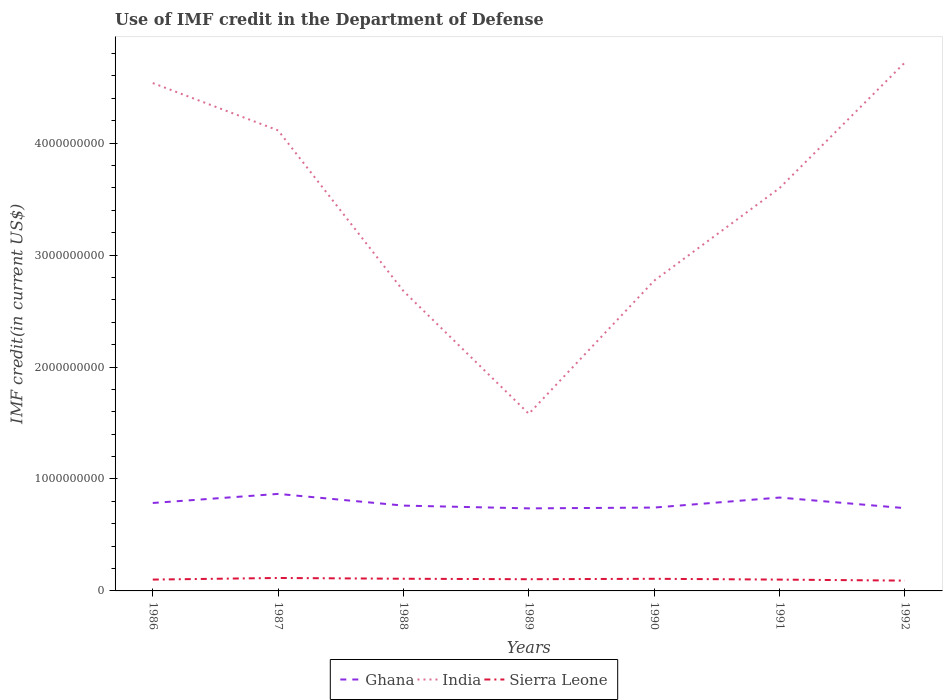How many different coloured lines are there?
Provide a succinct answer. 3. Across all years, what is the maximum IMF credit in the Department of Defense in Sierra Leone?
Your answer should be very brief. 9.21e+07. What is the total IMF credit in the Department of Defense in India in the graph?
Keep it short and to the point. -3.14e+09. What is the difference between the highest and the second highest IMF credit in the Department of Defense in Ghana?
Your answer should be compact. 1.29e+08. How many years are there in the graph?
Provide a succinct answer. 7. What is the difference between two consecutive major ticks on the Y-axis?
Provide a succinct answer. 1.00e+09. Are the values on the major ticks of Y-axis written in scientific E-notation?
Give a very brief answer. No. Does the graph contain grids?
Ensure brevity in your answer.  No. Where does the legend appear in the graph?
Provide a short and direct response. Bottom center. How are the legend labels stacked?
Ensure brevity in your answer.  Horizontal. What is the title of the graph?
Provide a short and direct response. Use of IMF credit in the Department of Defense. Does "Czech Republic" appear as one of the legend labels in the graph?
Your answer should be compact. No. What is the label or title of the Y-axis?
Your answer should be compact. IMF credit(in current US$). What is the IMF credit(in current US$) of Ghana in 1986?
Provide a succinct answer. 7.86e+08. What is the IMF credit(in current US$) in India in 1986?
Offer a very short reply. 4.54e+09. What is the IMF credit(in current US$) in Sierra Leone in 1986?
Your answer should be very brief. 1.01e+08. What is the IMF credit(in current US$) of Ghana in 1987?
Give a very brief answer. 8.67e+08. What is the IMF credit(in current US$) of India in 1987?
Make the answer very short. 4.11e+09. What is the IMF credit(in current US$) of Sierra Leone in 1987?
Provide a succinct answer. 1.16e+08. What is the IMF credit(in current US$) of Ghana in 1988?
Ensure brevity in your answer.  7.62e+08. What is the IMF credit(in current US$) of India in 1988?
Your answer should be very brief. 2.68e+09. What is the IMF credit(in current US$) in Sierra Leone in 1988?
Make the answer very short. 1.09e+08. What is the IMF credit(in current US$) of Ghana in 1989?
Make the answer very short. 7.37e+08. What is the IMF credit(in current US$) in India in 1989?
Give a very brief answer. 1.58e+09. What is the IMF credit(in current US$) in Sierra Leone in 1989?
Your answer should be very brief. 1.05e+08. What is the IMF credit(in current US$) in Ghana in 1990?
Your response must be concise. 7.45e+08. What is the IMF credit(in current US$) of India in 1990?
Offer a terse response. 2.77e+09. What is the IMF credit(in current US$) of Sierra Leone in 1990?
Provide a short and direct response. 1.08e+08. What is the IMF credit(in current US$) in Ghana in 1991?
Give a very brief answer. 8.34e+08. What is the IMF credit(in current US$) in India in 1991?
Your answer should be very brief. 3.60e+09. What is the IMF credit(in current US$) in Sierra Leone in 1991?
Your response must be concise. 1.01e+08. What is the IMF credit(in current US$) of Ghana in 1992?
Your response must be concise. 7.40e+08. What is the IMF credit(in current US$) of India in 1992?
Offer a very short reply. 4.72e+09. What is the IMF credit(in current US$) of Sierra Leone in 1992?
Give a very brief answer. 9.21e+07. Across all years, what is the maximum IMF credit(in current US$) of Ghana?
Your answer should be very brief. 8.67e+08. Across all years, what is the maximum IMF credit(in current US$) in India?
Your response must be concise. 4.72e+09. Across all years, what is the maximum IMF credit(in current US$) of Sierra Leone?
Ensure brevity in your answer.  1.16e+08. Across all years, what is the minimum IMF credit(in current US$) of Ghana?
Ensure brevity in your answer.  7.37e+08. Across all years, what is the minimum IMF credit(in current US$) of India?
Keep it short and to the point. 1.58e+09. Across all years, what is the minimum IMF credit(in current US$) in Sierra Leone?
Your answer should be very brief. 9.21e+07. What is the total IMF credit(in current US$) in Ghana in the graph?
Your answer should be very brief. 5.47e+09. What is the total IMF credit(in current US$) in India in the graph?
Provide a short and direct response. 2.40e+1. What is the total IMF credit(in current US$) in Sierra Leone in the graph?
Provide a short and direct response. 7.32e+08. What is the difference between the IMF credit(in current US$) of Ghana in 1986 and that in 1987?
Give a very brief answer. -8.11e+07. What is the difference between the IMF credit(in current US$) of India in 1986 and that in 1987?
Make the answer very short. 4.23e+08. What is the difference between the IMF credit(in current US$) in Sierra Leone in 1986 and that in 1987?
Offer a very short reply. -1.43e+07. What is the difference between the IMF credit(in current US$) in Ghana in 1986 and that in 1988?
Provide a succinct answer. 2.34e+07. What is the difference between the IMF credit(in current US$) of India in 1986 and that in 1988?
Make the answer very short. 1.86e+09. What is the difference between the IMF credit(in current US$) in Sierra Leone in 1986 and that in 1988?
Ensure brevity in your answer.  -7.39e+06. What is the difference between the IMF credit(in current US$) in Ghana in 1986 and that in 1989?
Make the answer very short. 4.82e+07. What is the difference between the IMF credit(in current US$) in India in 1986 and that in 1989?
Make the answer very short. 2.95e+09. What is the difference between the IMF credit(in current US$) in Sierra Leone in 1986 and that in 1989?
Give a very brief answer. -3.18e+06. What is the difference between the IMF credit(in current US$) of Ghana in 1986 and that in 1990?
Your response must be concise. 4.10e+07. What is the difference between the IMF credit(in current US$) of India in 1986 and that in 1990?
Give a very brief answer. 1.77e+09. What is the difference between the IMF credit(in current US$) of Sierra Leone in 1986 and that in 1990?
Give a very brief answer. -7.01e+06. What is the difference between the IMF credit(in current US$) in Ghana in 1986 and that in 1991?
Provide a short and direct response. -4.85e+07. What is the difference between the IMF credit(in current US$) of India in 1986 and that in 1991?
Your answer should be very brief. 9.38e+08. What is the difference between the IMF credit(in current US$) of Sierra Leone in 1986 and that in 1991?
Provide a succinct answer. 2.07e+05. What is the difference between the IMF credit(in current US$) of Ghana in 1986 and that in 1992?
Your answer should be compact. 4.61e+07. What is the difference between the IMF credit(in current US$) in India in 1986 and that in 1992?
Keep it short and to the point. -1.84e+08. What is the difference between the IMF credit(in current US$) of Sierra Leone in 1986 and that in 1992?
Your response must be concise. 9.26e+06. What is the difference between the IMF credit(in current US$) in Ghana in 1987 and that in 1988?
Ensure brevity in your answer.  1.05e+08. What is the difference between the IMF credit(in current US$) of India in 1987 and that in 1988?
Offer a very short reply. 1.44e+09. What is the difference between the IMF credit(in current US$) of Sierra Leone in 1987 and that in 1988?
Your answer should be very brief. 6.94e+06. What is the difference between the IMF credit(in current US$) in Ghana in 1987 and that in 1989?
Provide a succinct answer. 1.29e+08. What is the difference between the IMF credit(in current US$) in India in 1987 and that in 1989?
Offer a terse response. 2.53e+09. What is the difference between the IMF credit(in current US$) in Sierra Leone in 1987 and that in 1989?
Provide a short and direct response. 1.12e+07. What is the difference between the IMF credit(in current US$) of Ghana in 1987 and that in 1990?
Ensure brevity in your answer.  1.22e+08. What is the difference between the IMF credit(in current US$) in India in 1987 and that in 1990?
Ensure brevity in your answer.  1.34e+09. What is the difference between the IMF credit(in current US$) of Sierra Leone in 1987 and that in 1990?
Provide a short and direct response. 7.31e+06. What is the difference between the IMF credit(in current US$) of Ghana in 1987 and that in 1991?
Ensure brevity in your answer.  3.26e+07. What is the difference between the IMF credit(in current US$) of India in 1987 and that in 1991?
Your response must be concise. 5.15e+08. What is the difference between the IMF credit(in current US$) of Sierra Leone in 1987 and that in 1991?
Give a very brief answer. 1.45e+07. What is the difference between the IMF credit(in current US$) in Ghana in 1987 and that in 1992?
Give a very brief answer. 1.27e+08. What is the difference between the IMF credit(in current US$) in India in 1987 and that in 1992?
Your answer should be very brief. -6.07e+08. What is the difference between the IMF credit(in current US$) in Sierra Leone in 1987 and that in 1992?
Your answer should be compact. 2.36e+07. What is the difference between the IMF credit(in current US$) of Ghana in 1988 and that in 1989?
Your response must be concise. 2.48e+07. What is the difference between the IMF credit(in current US$) in India in 1988 and that in 1989?
Provide a succinct answer. 1.10e+09. What is the difference between the IMF credit(in current US$) in Sierra Leone in 1988 and that in 1989?
Provide a succinct answer. 4.21e+06. What is the difference between the IMF credit(in current US$) in Ghana in 1988 and that in 1990?
Make the answer very short. 1.75e+07. What is the difference between the IMF credit(in current US$) of India in 1988 and that in 1990?
Provide a short and direct response. -9.29e+07. What is the difference between the IMF credit(in current US$) in Sierra Leone in 1988 and that in 1990?
Ensure brevity in your answer.  3.74e+05. What is the difference between the IMF credit(in current US$) of Ghana in 1988 and that in 1991?
Give a very brief answer. -7.20e+07. What is the difference between the IMF credit(in current US$) of India in 1988 and that in 1991?
Offer a very short reply. -9.20e+08. What is the difference between the IMF credit(in current US$) of Sierra Leone in 1988 and that in 1991?
Give a very brief answer. 7.60e+06. What is the difference between the IMF credit(in current US$) in Ghana in 1988 and that in 1992?
Your response must be concise. 2.26e+07. What is the difference between the IMF credit(in current US$) of India in 1988 and that in 1992?
Provide a succinct answer. -2.04e+09. What is the difference between the IMF credit(in current US$) of Sierra Leone in 1988 and that in 1992?
Give a very brief answer. 1.66e+07. What is the difference between the IMF credit(in current US$) of Ghana in 1989 and that in 1990?
Keep it short and to the point. -7.23e+06. What is the difference between the IMF credit(in current US$) of India in 1989 and that in 1990?
Offer a terse response. -1.19e+09. What is the difference between the IMF credit(in current US$) in Sierra Leone in 1989 and that in 1990?
Offer a terse response. -3.84e+06. What is the difference between the IMF credit(in current US$) in Ghana in 1989 and that in 1991?
Provide a succinct answer. -9.67e+07. What is the difference between the IMF credit(in current US$) of India in 1989 and that in 1991?
Make the answer very short. -2.02e+09. What is the difference between the IMF credit(in current US$) in Sierra Leone in 1989 and that in 1991?
Keep it short and to the point. 3.38e+06. What is the difference between the IMF credit(in current US$) of Ghana in 1989 and that in 1992?
Provide a succinct answer. -2.15e+06. What is the difference between the IMF credit(in current US$) of India in 1989 and that in 1992?
Provide a short and direct response. -3.14e+09. What is the difference between the IMF credit(in current US$) of Sierra Leone in 1989 and that in 1992?
Your answer should be very brief. 1.24e+07. What is the difference between the IMF credit(in current US$) in Ghana in 1990 and that in 1991?
Your answer should be very brief. -8.95e+07. What is the difference between the IMF credit(in current US$) in India in 1990 and that in 1991?
Provide a succinct answer. -8.27e+08. What is the difference between the IMF credit(in current US$) of Sierra Leone in 1990 and that in 1991?
Provide a succinct answer. 7.22e+06. What is the difference between the IMF credit(in current US$) of Ghana in 1990 and that in 1992?
Provide a short and direct response. 5.08e+06. What is the difference between the IMF credit(in current US$) of India in 1990 and that in 1992?
Provide a succinct answer. -1.95e+09. What is the difference between the IMF credit(in current US$) in Sierra Leone in 1990 and that in 1992?
Provide a succinct answer. 1.63e+07. What is the difference between the IMF credit(in current US$) of Ghana in 1991 and that in 1992?
Your answer should be very brief. 9.46e+07. What is the difference between the IMF credit(in current US$) in India in 1991 and that in 1992?
Your answer should be very brief. -1.12e+09. What is the difference between the IMF credit(in current US$) in Sierra Leone in 1991 and that in 1992?
Your answer should be very brief. 9.05e+06. What is the difference between the IMF credit(in current US$) of Ghana in 1986 and the IMF credit(in current US$) of India in 1987?
Provide a succinct answer. -3.33e+09. What is the difference between the IMF credit(in current US$) of Ghana in 1986 and the IMF credit(in current US$) of Sierra Leone in 1987?
Provide a succinct answer. 6.70e+08. What is the difference between the IMF credit(in current US$) in India in 1986 and the IMF credit(in current US$) in Sierra Leone in 1987?
Offer a very short reply. 4.42e+09. What is the difference between the IMF credit(in current US$) in Ghana in 1986 and the IMF credit(in current US$) in India in 1988?
Provide a short and direct response. -1.89e+09. What is the difference between the IMF credit(in current US$) of Ghana in 1986 and the IMF credit(in current US$) of Sierra Leone in 1988?
Give a very brief answer. 6.77e+08. What is the difference between the IMF credit(in current US$) in India in 1986 and the IMF credit(in current US$) in Sierra Leone in 1988?
Your response must be concise. 4.43e+09. What is the difference between the IMF credit(in current US$) in Ghana in 1986 and the IMF credit(in current US$) in India in 1989?
Give a very brief answer. -7.97e+08. What is the difference between the IMF credit(in current US$) in Ghana in 1986 and the IMF credit(in current US$) in Sierra Leone in 1989?
Your response must be concise. 6.81e+08. What is the difference between the IMF credit(in current US$) in India in 1986 and the IMF credit(in current US$) in Sierra Leone in 1989?
Offer a very short reply. 4.43e+09. What is the difference between the IMF credit(in current US$) of Ghana in 1986 and the IMF credit(in current US$) of India in 1990?
Offer a very short reply. -1.99e+09. What is the difference between the IMF credit(in current US$) in Ghana in 1986 and the IMF credit(in current US$) in Sierra Leone in 1990?
Offer a very short reply. 6.77e+08. What is the difference between the IMF credit(in current US$) in India in 1986 and the IMF credit(in current US$) in Sierra Leone in 1990?
Ensure brevity in your answer.  4.43e+09. What is the difference between the IMF credit(in current US$) of Ghana in 1986 and the IMF credit(in current US$) of India in 1991?
Offer a terse response. -2.81e+09. What is the difference between the IMF credit(in current US$) of Ghana in 1986 and the IMF credit(in current US$) of Sierra Leone in 1991?
Offer a very short reply. 6.84e+08. What is the difference between the IMF credit(in current US$) in India in 1986 and the IMF credit(in current US$) in Sierra Leone in 1991?
Provide a succinct answer. 4.44e+09. What is the difference between the IMF credit(in current US$) in Ghana in 1986 and the IMF credit(in current US$) in India in 1992?
Keep it short and to the point. -3.93e+09. What is the difference between the IMF credit(in current US$) of Ghana in 1986 and the IMF credit(in current US$) of Sierra Leone in 1992?
Provide a succinct answer. 6.94e+08. What is the difference between the IMF credit(in current US$) of India in 1986 and the IMF credit(in current US$) of Sierra Leone in 1992?
Offer a terse response. 4.44e+09. What is the difference between the IMF credit(in current US$) in Ghana in 1987 and the IMF credit(in current US$) in India in 1988?
Provide a succinct answer. -1.81e+09. What is the difference between the IMF credit(in current US$) in Ghana in 1987 and the IMF credit(in current US$) in Sierra Leone in 1988?
Your answer should be compact. 7.58e+08. What is the difference between the IMF credit(in current US$) in India in 1987 and the IMF credit(in current US$) in Sierra Leone in 1988?
Your answer should be very brief. 4.00e+09. What is the difference between the IMF credit(in current US$) of Ghana in 1987 and the IMF credit(in current US$) of India in 1989?
Your response must be concise. -7.16e+08. What is the difference between the IMF credit(in current US$) of Ghana in 1987 and the IMF credit(in current US$) of Sierra Leone in 1989?
Provide a succinct answer. 7.62e+08. What is the difference between the IMF credit(in current US$) in India in 1987 and the IMF credit(in current US$) in Sierra Leone in 1989?
Offer a terse response. 4.01e+09. What is the difference between the IMF credit(in current US$) of Ghana in 1987 and the IMF credit(in current US$) of India in 1990?
Give a very brief answer. -1.90e+09. What is the difference between the IMF credit(in current US$) of Ghana in 1987 and the IMF credit(in current US$) of Sierra Leone in 1990?
Provide a succinct answer. 7.58e+08. What is the difference between the IMF credit(in current US$) of India in 1987 and the IMF credit(in current US$) of Sierra Leone in 1990?
Give a very brief answer. 4.01e+09. What is the difference between the IMF credit(in current US$) in Ghana in 1987 and the IMF credit(in current US$) in India in 1991?
Provide a succinct answer. -2.73e+09. What is the difference between the IMF credit(in current US$) of Ghana in 1987 and the IMF credit(in current US$) of Sierra Leone in 1991?
Provide a succinct answer. 7.66e+08. What is the difference between the IMF credit(in current US$) of India in 1987 and the IMF credit(in current US$) of Sierra Leone in 1991?
Your answer should be compact. 4.01e+09. What is the difference between the IMF credit(in current US$) of Ghana in 1987 and the IMF credit(in current US$) of India in 1992?
Make the answer very short. -3.85e+09. What is the difference between the IMF credit(in current US$) of Ghana in 1987 and the IMF credit(in current US$) of Sierra Leone in 1992?
Offer a terse response. 7.75e+08. What is the difference between the IMF credit(in current US$) of India in 1987 and the IMF credit(in current US$) of Sierra Leone in 1992?
Keep it short and to the point. 4.02e+09. What is the difference between the IMF credit(in current US$) in Ghana in 1988 and the IMF credit(in current US$) in India in 1989?
Make the answer very short. -8.20e+08. What is the difference between the IMF credit(in current US$) in Ghana in 1988 and the IMF credit(in current US$) in Sierra Leone in 1989?
Your answer should be compact. 6.58e+08. What is the difference between the IMF credit(in current US$) of India in 1988 and the IMF credit(in current US$) of Sierra Leone in 1989?
Offer a very short reply. 2.57e+09. What is the difference between the IMF credit(in current US$) of Ghana in 1988 and the IMF credit(in current US$) of India in 1990?
Keep it short and to the point. -2.01e+09. What is the difference between the IMF credit(in current US$) of Ghana in 1988 and the IMF credit(in current US$) of Sierra Leone in 1990?
Offer a terse response. 6.54e+08. What is the difference between the IMF credit(in current US$) of India in 1988 and the IMF credit(in current US$) of Sierra Leone in 1990?
Offer a very short reply. 2.57e+09. What is the difference between the IMF credit(in current US$) of Ghana in 1988 and the IMF credit(in current US$) of India in 1991?
Offer a terse response. -2.84e+09. What is the difference between the IMF credit(in current US$) of Ghana in 1988 and the IMF credit(in current US$) of Sierra Leone in 1991?
Offer a terse response. 6.61e+08. What is the difference between the IMF credit(in current US$) in India in 1988 and the IMF credit(in current US$) in Sierra Leone in 1991?
Give a very brief answer. 2.58e+09. What is the difference between the IMF credit(in current US$) of Ghana in 1988 and the IMF credit(in current US$) of India in 1992?
Offer a very short reply. -3.96e+09. What is the difference between the IMF credit(in current US$) in Ghana in 1988 and the IMF credit(in current US$) in Sierra Leone in 1992?
Provide a short and direct response. 6.70e+08. What is the difference between the IMF credit(in current US$) in India in 1988 and the IMF credit(in current US$) in Sierra Leone in 1992?
Provide a short and direct response. 2.59e+09. What is the difference between the IMF credit(in current US$) in Ghana in 1989 and the IMF credit(in current US$) in India in 1990?
Your answer should be compact. -2.03e+09. What is the difference between the IMF credit(in current US$) of Ghana in 1989 and the IMF credit(in current US$) of Sierra Leone in 1990?
Make the answer very short. 6.29e+08. What is the difference between the IMF credit(in current US$) in India in 1989 and the IMF credit(in current US$) in Sierra Leone in 1990?
Give a very brief answer. 1.47e+09. What is the difference between the IMF credit(in current US$) in Ghana in 1989 and the IMF credit(in current US$) in India in 1991?
Make the answer very short. -2.86e+09. What is the difference between the IMF credit(in current US$) of Ghana in 1989 and the IMF credit(in current US$) of Sierra Leone in 1991?
Your answer should be very brief. 6.36e+08. What is the difference between the IMF credit(in current US$) in India in 1989 and the IMF credit(in current US$) in Sierra Leone in 1991?
Provide a short and direct response. 1.48e+09. What is the difference between the IMF credit(in current US$) of Ghana in 1989 and the IMF credit(in current US$) of India in 1992?
Keep it short and to the point. -3.98e+09. What is the difference between the IMF credit(in current US$) in Ghana in 1989 and the IMF credit(in current US$) in Sierra Leone in 1992?
Offer a very short reply. 6.45e+08. What is the difference between the IMF credit(in current US$) in India in 1989 and the IMF credit(in current US$) in Sierra Leone in 1992?
Your answer should be very brief. 1.49e+09. What is the difference between the IMF credit(in current US$) in Ghana in 1990 and the IMF credit(in current US$) in India in 1991?
Offer a terse response. -2.85e+09. What is the difference between the IMF credit(in current US$) of Ghana in 1990 and the IMF credit(in current US$) of Sierra Leone in 1991?
Your answer should be compact. 6.43e+08. What is the difference between the IMF credit(in current US$) of India in 1990 and the IMF credit(in current US$) of Sierra Leone in 1991?
Ensure brevity in your answer.  2.67e+09. What is the difference between the IMF credit(in current US$) of Ghana in 1990 and the IMF credit(in current US$) of India in 1992?
Your answer should be very brief. -3.98e+09. What is the difference between the IMF credit(in current US$) of Ghana in 1990 and the IMF credit(in current US$) of Sierra Leone in 1992?
Make the answer very short. 6.53e+08. What is the difference between the IMF credit(in current US$) of India in 1990 and the IMF credit(in current US$) of Sierra Leone in 1992?
Give a very brief answer. 2.68e+09. What is the difference between the IMF credit(in current US$) in Ghana in 1991 and the IMF credit(in current US$) in India in 1992?
Give a very brief answer. -3.89e+09. What is the difference between the IMF credit(in current US$) in Ghana in 1991 and the IMF credit(in current US$) in Sierra Leone in 1992?
Keep it short and to the point. 7.42e+08. What is the difference between the IMF credit(in current US$) in India in 1991 and the IMF credit(in current US$) in Sierra Leone in 1992?
Your response must be concise. 3.51e+09. What is the average IMF credit(in current US$) of Ghana per year?
Provide a short and direct response. 7.81e+08. What is the average IMF credit(in current US$) in India per year?
Your answer should be compact. 3.43e+09. What is the average IMF credit(in current US$) of Sierra Leone per year?
Your answer should be compact. 1.05e+08. In the year 1986, what is the difference between the IMF credit(in current US$) of Ghana and IMF credit(in current US$) of India?
Offer a terse response. -3.75e+09. In the year 1986, what is the difference between the IMF credit(in current US$) of Ghana and IMF credit(in current US$) of Sierra Leone?
Your answer should be compact. 6.84e+08. In the year 1986, what is the difference between the IMF credit(in current US$) in India and IMF credit(in current US$) in Sierra Leone?
Make the answer very short. 4.44e+09. In the year 1987, what is the difference between the IMF credit(in current US$) of Ghana and IMF credit(in current US$) of India?
Offer a very short reply. -3.25e+09. In the year 1987, what is the difference between the IMF credit(in current US$) of Ghana and IMF credit(in current US$) of Sierra Leone?
Your answer should be very brief. 7.51e+08. In the year 1987, what is the difference between the IMF credit(in current US$) in India and IMF credit(in current US$) in Sierra Leone?
Make the answer very short. 4.00e+09. In the year 1988, what is the difference between the IMF credit(in current US$) in Ghana and IMF credit(in current US$) in India?
Offer a terse response. -1.92e+09. In the year 1988, what is the difference between the IMF credit(in current US$) of Ghana and IMF credit(in current US$) of Sierra Leone?
Provide a succinct answer. 6.53e+08. In the year 1988, what is the difference between the IMF credit(in current US$) of India and IMF credit(in current US$) of Sierra Leone?
Your response must be concise. 2.57e+09. In the year 1989, what is the difference between the IMF credit(in current US$) of Ghana and IMF credit(in current US$) of India?
Give a very brief answer. -8.45e+08. In the year 1989, what is the difference between the IMF credit(in current US$) in Ghana and IMF credit(in current US$) in Sierra Leone?
Offer a very short reply. 6.33e+08. In the year 1989, what is the difference between the IMF credit(in current US$) of India and IMF credit(in current US$) of Sierra Leone?
Offer a terse response. 1.48e+09. In the year 1990, what is the difference between the IMF credit(in current US$) of Ghana and IMF credit(in current US$) of India?
Offer a terse response. -2.03e+09. In the year 1990, what is the difference between the IMF credit(in current US$) in Ghana and IMF credit(in current US$) in Sierra Leone?
Your answer should be compact. 6.36e+08. In the year 1990, what is the difference between the IMF credit(in current US$) of India and IMF credit(in current US$) of Sierra Leone?
Ensure brevity in your answer.  2.66e+09. In the year 1991, what is the difference between the IMF credit(in current US$) of Ghana and IMF credit(in current US$) of India?
Give a very brief answer. -2.76e+09. In the year 1991, what is the difference between the IMF credit(in current US$) in Ghana and IMF credit(in current US$) in Sierra Leone?
Provide a succinct answer. 7.33e+08. In the year 1991, what is the difference between the IMF credit(in current US$) of India and IMF credit(in current US$) of Sierra Leone?
Ensure brevity in your answer.  3.50e+09. In the year 1992, what is the difference between the IMF credit(in current US$) of Ghana and IMF credit(in current US$) of India?
Provide a succinct answer. -3.98e+09. In the year 1992, what is the difference between the IMF credit(in current US$) of Ghana and IMF credit(in current US$) of Sierra Leone?
Your response must be concise. 6.47e+08. In the year 1992, what is the difference between the IMF credit(in current US$) in India and IMF credit(in current US$) in Sierra Leone?
Offer a very short reply. 4.63e+09. What is the ratio of the IMF credit(in current US$) in Ghana in 1986 to that in 1987?
Make the answer very short. 0.91. What is the ratio of the IMF credit(in current US$) of India in 1986 to that in 1987?
Offer a very short reply. 1.1. What is the ratio of the IMF credit(in current US$) of Sierra Leone in 1986 to that in 1987?
Your response must be concise. 0.88. What is the ratio of the IMF credit(in current US$) in Ghana in 1986 to that in 1988?
Provide a short and direct response. 1.03. What is the ratio of the IMF credit(in current US$) in India in 1986 to that in 1988?
Your response must be concise. 1.69. What is the ratio of the IMF credit(in current US$) of Sierra Leone in 1986 to that in 1988?
Provide a succinct answer. 0.93. What is the ratio of the IMF credit(in current US$) in Ghana in 1986 to that in 1989?
Make the answer very short. 1.07. What is the ratio of the IMF credit(in current US$) in India in 1986 to that in 1989?
Keep it short and to the point. 2.87. What is the ratio of the IMF credit(in current US$) in Sierra Leone in 1986 to that in 1989?
Offer a very short reply. 0.97. What is the ratio of the IMF credit(in current US$) in Ghana in 1986 to that in 1990?
Provide a short and direct response. 1.06. What is the ratio of the IMF credit(in current US$) in India in 1986 to that in 1990?
Your response must be concise. 1.64. What is the ratio of the IMF credit(in current US$) in Sierra Leone in 1986 to that in 1990?
Your response must be concise. 0.94. What is the ratio of the IMF credit(in current US$) of Ghana in 1986 to that in 1991?
Your answer should be very brief. 0.94. What is the ratio of the IMF credit(in current US$) of India in 1986 to that in 1991?
Your response must be concise. 1.26. What is the ratio of the IMF credit(in current US$) in Sierra Leone in 1986 to that in 1991?
Give a very brief answer. 1. What is the ratio of the IMF credit(in current US$) in Ghana in 1986 to that in 1992?
Your answer should be very brief. 1.06. What is the ratio of the IMF credit(in current US$) of India in 1986 to that in 1992?
Your response must be concise. 0.96. What is the ratio of the IMF credit(in current US$) of Sierra Leone in 1986 to that in 1992?
Offer a terse response. 1.1. What is the ratio of the IMF credit(in current US$) of Ghana in 1987 to that in 1988?
Ensure brevity in your answer.  1.14. What is the ratio of the IMF credit(in current US$) in India in 1987 to that in 1988?
Your answer should be very brief. 1.54. What is the ratio of the IMF credit(in current US$) in Sierra Leone in 1987 to that in 1988?
Make the answer very short. 1.06. What is the ratio of the IMF credit(in current US$) in Ghana in 1987 to that in 1989?
Offer a terse response. 1.18. What is the ratio of the IMF credit(in current US$) of India in 1987 to that in 1989?
Your answer should be very brief. 2.6. What is the ratio of the IMF credit(in current US$) of Sierra Leone in 1987 to that in 1989?
Your response must be concise. 1.11. What is the ratio of the IMF credit(in current US$) of Ghana in 1987 to that in 1990?
Give a very brief answer. 1.16. What is the ratio of the IMF credit(in current US$) in India in 1987 to that in 1990?
Offer a terse response. 1.48. What is the ratio of the IMF credit(in current US$) of Sierra Leone in 1987 to that in 1990?
Ensure brevity in your answer.  1.07. What is the ratio of the IMF credit(in current US$) in Ghana in 1987 to that in 1991?
Make the answer very short. 1.04. What is the ratio of the IMF credit(in current US$) of India in 1987 to that in 1991?
Ensure brevity in your answer.  1.14. What is the ratio of the IMF credit(in current US$) of Sierra Leone in 1987 to that in 1991?
Your answer should be compact. 1.14. What is the ratio of the IMF credit(in current US$) of Ghana in 1987 to that in 1992?
Offer a very short reply. 1.17. What is the ratio of the IMF credit(in current US$) of India in 1987 to that in 1992?
Offer a very short reply. 0.87. What is the ratio of the IMF credit(in current US$) in Sierra Leone in 1987 to that in 1992?
Provide a succinct answer. 1.26. What is the ratio of the IMF credit(in current US$) in Ghana in 1988 to that in 1989?
Your answer should be compact. 1.03. What is the ratio of the IMF credit(in current US$) of India in 1988 to that in 1989?
Your response must be concise. 1.69. What is the ratio of the IMF credit(in current US$) of Sierra Leone in 1988 to that in 1989?
Your answer should be compact. 1.04. What is the ratio of the IMF credit(in current US$) in Ghana in 1988 to that in 1990?
Offer a very short reply. 1.02. What is the ratio of the IMF credit(in current US$) of India in 1988 to that in 1990?
Your response must be concise. 0.97. What is the ratio of the IMF credit(in current US$) in Ghana in 1988 to that in 1991?
Give a very brief answer. 0.91. What is the ratio of the IMF credit(in current US$) in India in 1988 to that in 1991?
Your answer should be compact. 0.74. What is the ratio of the IMF credit(in current US$) of Sierra Leone in 1988 to that in 1991?
Make the answer very short. 1.08. What is the ratio of the IMF credit(in current US$) of Ghana in 1988 to that in 1992?
Your answer should be very brief. 1.03. What is the ratio of the IMF credit(in current US$) of India in 1988 to that in 1992?
Keep it short and to the point. 0.57. What is the ratio of the IMF credit(in current US$) in Sierra Leone in 1988 to that in 1992?
Keep it short and to the point. 1.18. What is the ratio of the IMF credit(in current US$) in Ghana in 1989 to that in 1990?
Offer a terse response. 0.99. What is the ratio of the IMF credit(in current US$) of India in 1989 to that in 1990?
Offer a very short reply. 0.57. What is the ratio of the IMF credit(in current US$) in Sierra Leone in 1989 to that in 1990?
Your answer should be very brief. 0.96. What is the ratio of the IMF credit(in current US$) of Ghana in 1989 to that in 1991?
Offer a very short reply. 0.88. What is the ratio of the IMF credit(in current US$) of India in 1989 to that in 1991?
Make the answer very short. 0.44. What is the ratio of the IMF credit(in current US$) of Sierra Leone in 1989 to that in 1991?
Ensure brevity in your answer.  1.03. What is the ratio of the IMF credit(in current US$) of Ghana in 1989 to that in 1992?
Give a very brief answer. 1. What is the ratio of the IMF credit(in current US$) of India in 1989 to that in 1992?
Give a very brief answer. 0.34. What is the ratio of the IMF credit(in current US$) in Sierra Leone in 1989 to that in 1992?
Offer a very short reply. 1.14. What is the ratio of the IMF credit(in current US$) in Ghana in 1990 to that in 1991?
Give a very brief answer. 0.89. What is the ratio of the IMF credit(in current US$) in India in 1990 to that in 1991?
Your answer should be very brief. 0.77. What is the ratio of the IMF credit(in current US$) in Sierra Leone in 1990 to that in 1991?
Make the answer very short. 1.07. What is the ratio of the IMF credit(in current US$) in Ghana in 1990 to that in 1992?
Provide a succinct answer. 1.01. What is the ratio of the IMF credit(in current US$) in India in 1990 to that in 1992?
Provide a short and direct response. 0.59. What is the ratio of the IMF credit(in current US$) in Sierra Leone in 1990 to that in 1992?
Offer a very short reply. 1.18. What is the ratio of the IMF credit(in current US$) in Ghana in 1991 to that in 1992?
Provide a short and direct response. 1.13. What is the ratio of the IMF credit(in current US$) in India in 1991 to that in 1992?
Give a very brief answer. 0.76. What is the ratio of the IMF credit(in current US$) of Sierra Leone in 1991 to that in 1992?
Provide a succinct answer. 1.1. What is the difference between the highest and the second highest IMF credit(in current US$) of Ghana?
Your response must be concise. 3.26e+07. What is the difference between the highest and the second highest IMF credit(in current US$) in India?
Give a very brief answer. 1.84e+08. What is the difference between the highest and the second highest IMF credit(in current US$) in Sierra Leone?
Make the answer very short. 6.94e+06. What is the difference between the highest and the lowest IMF credit(in current US$) in Ghana?
Ensure brevity in your answer.  1.29e+08. What is the difference between the highest and the lowest IMF credit(in current US$) in India?
Make the answer very short. 3.14e+09. What is the difference between the highest and the lowest IMF credit(in current US$) in Sierra Leone?
Your answer should be compact. 2.36e+07. 